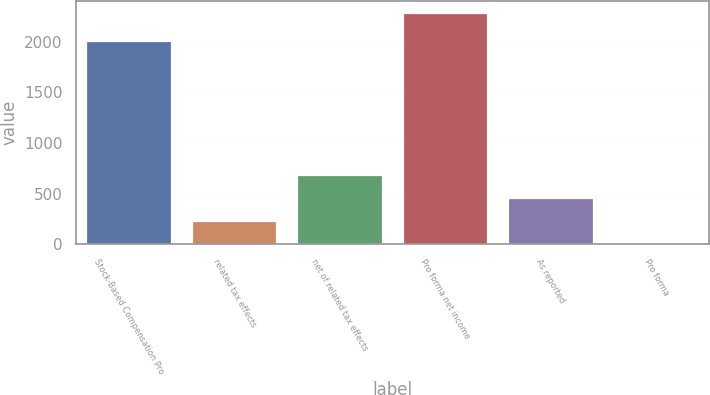Convert chart. <chart><loc_0><loc_0><loc_500><loc_500><bar_chart><fcel>Stock-Based Compensation Pro<fcel>related tax effects<fcel>net of related tax effects<fcel>Pro forma net income<fcel>As reported<fcel>Pro forma<nl><fcel>2003<fcel>231.23<fcel>687.85<fcel>2286<fcel>459.54<fcel>2.92<nl></chart> 